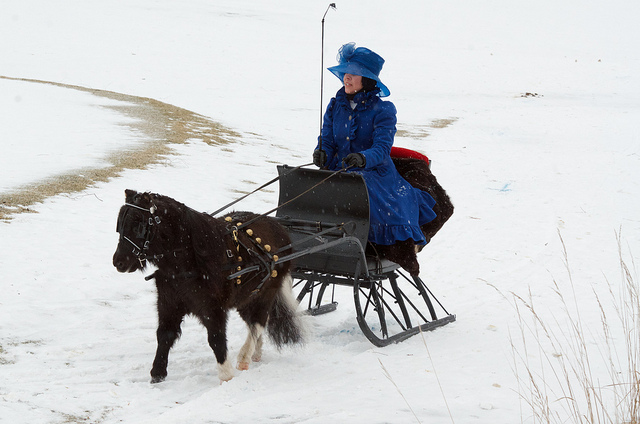Describe the attire of the person on the sled. The rider is wearing a traditional, Victorian-era style dress in bright blue, complete with a matching hat and cape. The color makes a bold statement against the snowy backdrop. Such attire is not meant for casual outings but for special occasions or themed events. 